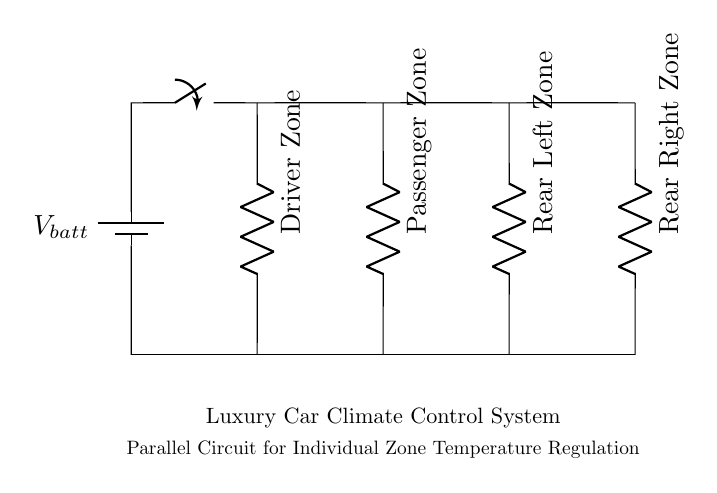What is the main power source for this circuit? The primary power source for this circuit is represented by the battery symbol labeled V_batt, indicating it provides the required voltage for the system.
Answer: V_batt How many resistors are in this circuit? The circuit clearly shows four resistors connected in parallel, each representing a different climate zone in the car.
Answer: Four What do the resistors represent in this context? Each resistor in the circuit represents a different climate zone's temperature regulation system (Driver, Passenger, Rear Left, Rear Right) within the luxury car's climate control system.
Answer: Temperature zones What is the total resistance if all resistors are the same value? In a parallel circuit, the total resistance can be calculated by taking the reciprocal of the sum of the reciprocals of the individual resistances; thus, if all resistors are of the same value R, the total resistance R_total is R/4.
Answer: R/4 If one zone's resistor fails, what happens to the others? Since this is a parallel circuit, if one resistor (zone) fails, the others continue to function normally, allowing for independent temperature control in the remaining zones.
Answer: They remain operational Which component regulates temperature individually in this diagram? The resistors, labeled for each zone, individually regulate the temperature based on user preferences for the corresponding climate zone in the vehicle.
Answer: Resistors What is the purpose of the switch in this circuit? The switch controls the flow of current from the battery to the climate control system, allowing users to turn the entire system on or off as desired.
Answer: Control system operation 